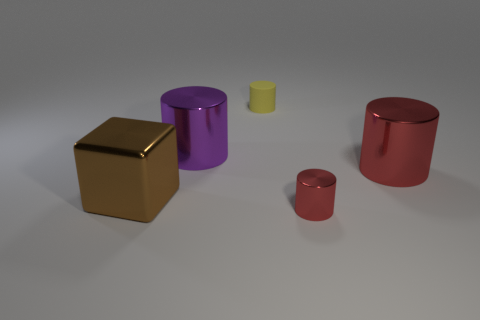Is the material of the tiny cylinder that is in front of the purple cylinder the same as the yellow thing to the right of the big brown shiny thing?
Provide a succinct answer. No. The thing that is the same color as the small shiny cylinder is what size?
Your response must be concise. Large. What is the large cylinder that is left of the tiny yellow object made of?
Your answer should be very brief. Metal. Does the tiny object in front of the purple metallic object have the same shape as the small thing behind the metallic cube?
Ensure brevity in your answer.  Yes. What is the material of the other cylinder that is the same color as the tiny metallic cylinder?
Your response must be concise. Metal. Is there a red cylinder?
Your answer should be compact. Yes. There is a yellow object that is the same shape as the tiny red shiny object; what is it made of?
Give a very brief answer. Rubber. Are there any large purple things on the right side of the small red cylinder?
Make the answer very short. No. Are the big cylinder right of the tiny rubber object and the yellow cylinder made of the same material?
Your response must be concise. No. Is there a metal object that has the same color as the large metal block?
Make the answer very short. No. 